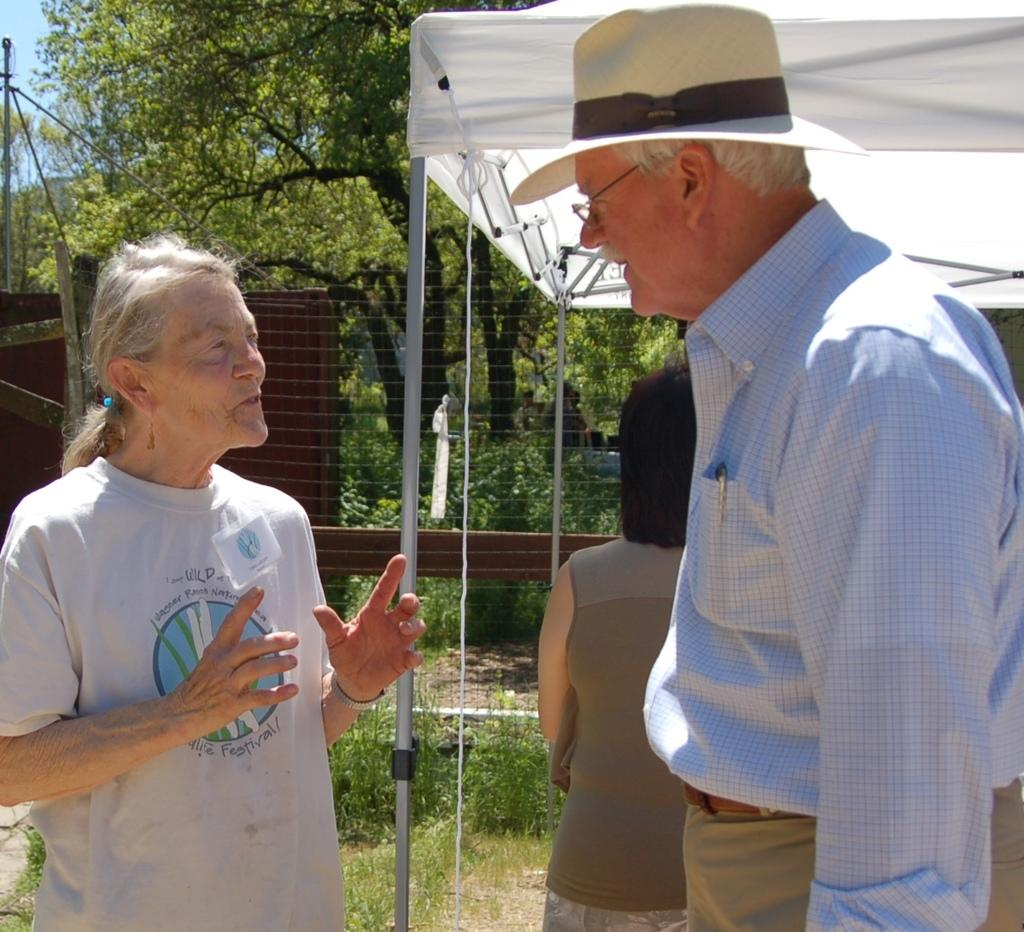How many people are in the image? There are three persons in the image. Can you describe the clothing of one of the persons? One person is wearing a hat. What type of natural elements can be seen in the image? There are trees and plants in the image. What man-made structures are present in the image? There are wires, a tent, and a wall in the image. What type of drum can be heard in the image? There is no drum present in the image, and therefore no sound can be heard. How many kittens are playing around the tent in the image? There are no kittens present in the image. 